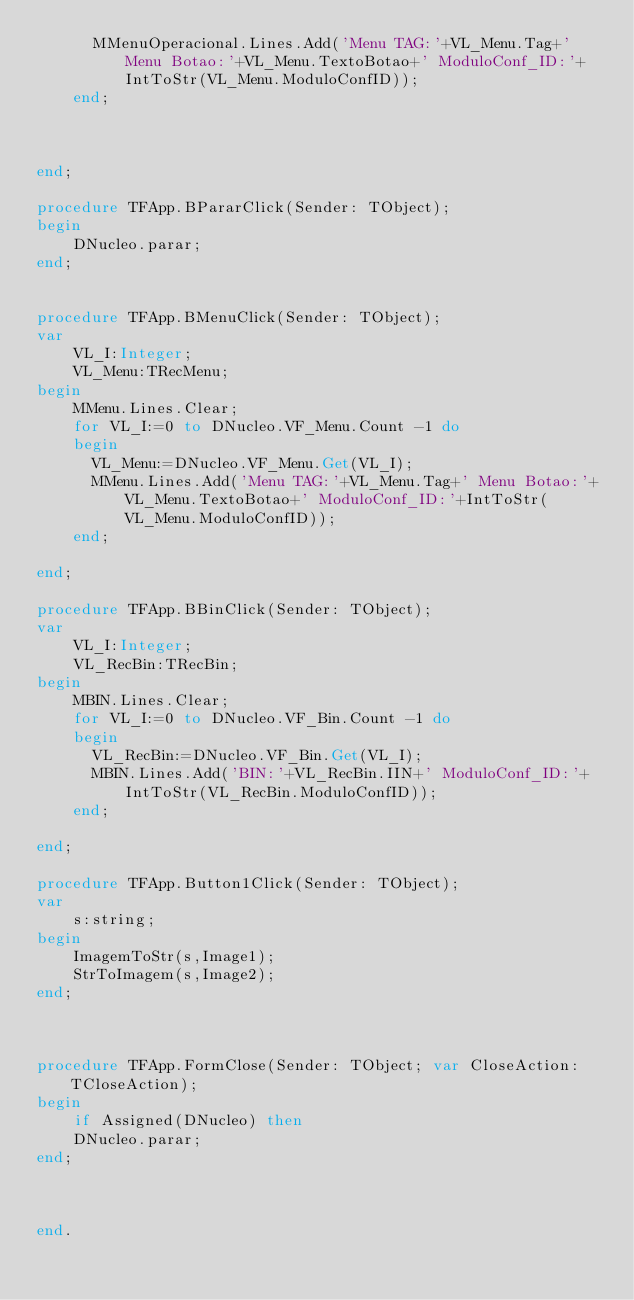<code> <loc_0><loc_0><loc_500><loc_500><_Pascal_>      MMenuOperacional.Lines.Add('Menu TAG:'+VL_Menu.Tag+' Menu Botao:'+VL_Menu.TextoBotao+' ModuloConf_ID:'+IntToStr(VL_Menu.ModuloConfID));
    end;



end;

procedure TFApp.BPararClick(Sender: TObject);
begin
    DNucleo.parar;
end;


procedure TFApp.BMenuClick(Sender: TObject);
var
    VL_I:Integer;
    VL_Menu:TRecMenu;
begin
    MMenu.Lines.Clear;
    for VL_I:=0 to DNucleo.VF_Menu.Count -1 do
    begin
      VL_Menu:=DNucleo.VF_Menu.Get(VL_I);
      MMenu.Lines.Add('Menu TAG:'+VL_Menu.Tag+' Menu Botao:'+VL_Menu.TextoBotao+' ModuloConf_ID:'+IntToStr(VL_Menu.ModuloConfID));
    end;

end;

procedure TFApp.BBinClick(Sender: TObject);
var
    VL_I:Integer;
    VL_RecBin:TRecBin;
begin
    MBIN.Lines.Clear;
    for VL_I:=0 to DNucleo.VF_Bin.Count -1 do
    begin
      VL_RecBin:=DNucleo.VF_Bin.Get(VL_I);
      MBIN.Lines.Add('BIN:'+VL_RecBin.IIN+' ModuloConf_ID:'+IntToStr(VL_RecBin.ModuloConfID));
    end;

end;

procedure TFApp.Button1Click(Sender: TObject);
var
    s:string;
begin
    ImagemToStr(s,Image1);
    StrToImagem(s,Image2);
end;



procedure TFApp.FormClose(Sender: TObject; var CloseAction: TCloseAction);
begin
    if Assigned(DNucleo) then
    DNucleo.parar;
end;



end.
</code> 